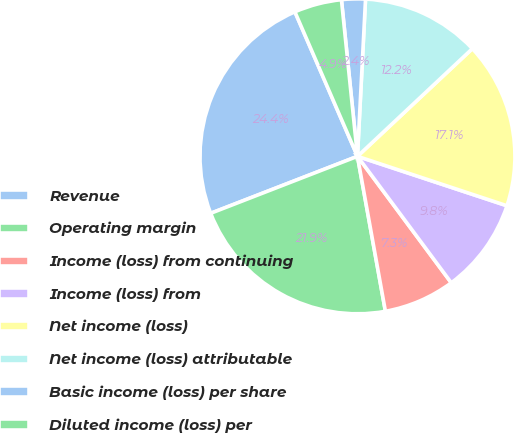<chart> <loc_0><loc_0><loc_500><loc_500><pie_chart><fcel>Revenue<fcel>Operating margin<fcel>Income (loss) from continuing<fcel>Income (loss) from<fcel>Net income (loss)<fcel>Net income (loss) attributable<fcel>Basic income (loss) per share<fcel>Diluted income (loss) per<nl><fcel>24.39%<fcel>21.95%<fcel>7.32%<fcel>9.76%<fcel>17.07%<fcel>12.2%<fcel>2.44%<fcel>4.88%<nl></chart> 